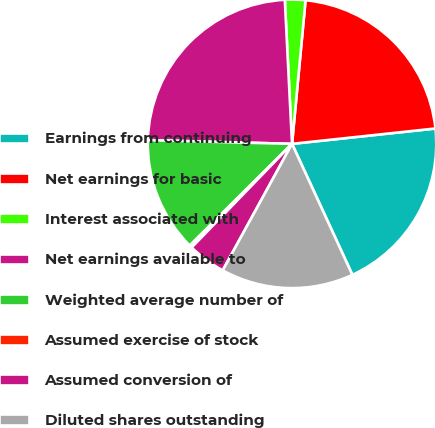<chart> <loc_0><loc_0><loc_500><loc_500><pie_chart><fcel>Earnings from continuing<fcel>Net earnings for basic<fcel>Interest associated with<fcel>Net earnings available to<fcel>Weighted average number of<fcel>Assumed exercise of stock<fcel>Assumed conversion of<fcel>Diluted shares outstanding<nl><fcel>19.83%<fcel>21.81%<fcel>2.29%<fcel>23.79%<fcel>12.87%<fcel>0.3%<fcel>4.27%<fcel>14.85%<nl></chart> 